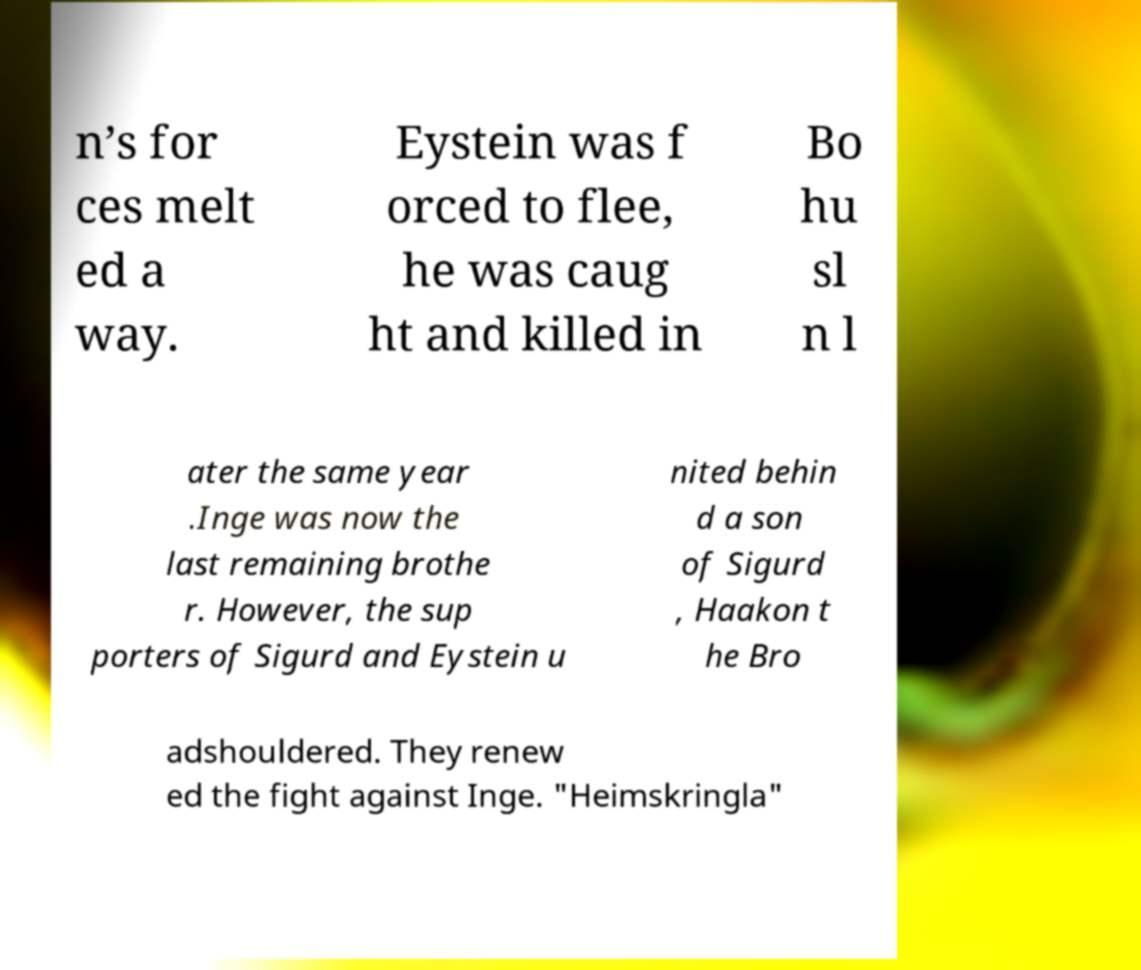What messages or text are displayed in this image? I need them in a readable, typed format. n’s for ces melt ed a way. Eystein was f orced to flee, he was caug ht and killed in Bo hu sl n l ater the same year .Inge was now the last remaining brothe r. However, the sup porters of Sigurd and Eystein u nited behin d a son of Sigurd , Haakon t he Bro adshouldered. They renew ed the fight against Inge. "Heimskringla" 